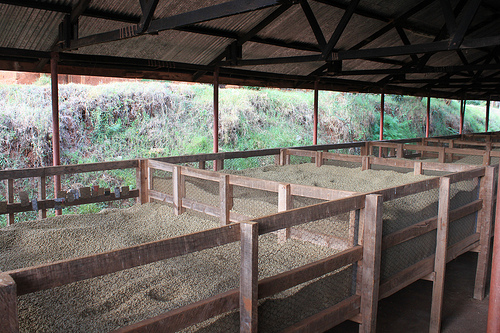<image>
Is there a wood beam under the ceiling? Yes. The wood beam is positioned underneath the ceiling, with the ceiling above it in the vertical space. 